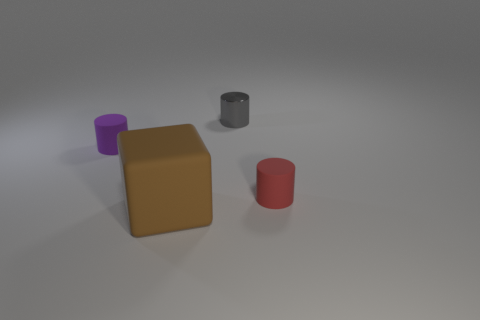What number of objects are either brown balls or big brown objects?
Provide a succinct answer. 1. Are there any matte cubes left of the small red rubber cylinder?
Your answer should be compact. Yes. Is there a purple object that has the same material as the block?
Keep it short and to the point. Yes. What number of balls are either small red rubber objects or small shiny objects?
Give a very brief answer. 0. Are there more big brown matte blocks that are right of the purple cylinder than small rubber cylinders right of the large brown rubber thing?
Your response must be concise. No. What is the size of the purple object that is made of the same material as the cube?
Your response must be concise. Small. How many objects are cylinders to the left of the brown block or gray metallic cubes?
Your answer should be compact. 1. What size is the red object that is the same shape as the purple thing?
Your answer should be very brief. Small. There is a tiny matte thing that is right of the purple object that is on the left side of the cylinder that is behind the purple rubber object; what color is it?
Keep it short and to the point. Red. Is the material of the tiny purple cylinder the same as the tiny red cylinder?
Provide a short and direct response. Yes. 